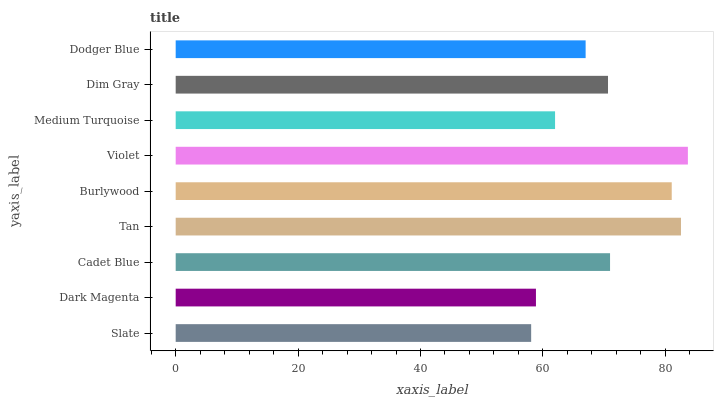Is Slate the minimum?
Answer yes or no. Yes. Is Violet the maximum?
Answer yes or no. Yes. Is Dark Magenta the minimum?
Answer yes or no. No. Is Dark Magenta the maximum?
Answer yes or no. No. Is Dark Magenta greater than Slate?
Answer yes or no. Yes. Is Slate less than Dark Magenta?
Answer yes or no. Yes. Is Slate greater than Dark Magenta?
Answer yes or no. No. Is Dark Magenta less than Slate?
Answer yes or no. No. Is Dim Gray the high median?
Answer yes or no. Yes. Is Dim Gray the low median?
Answer yes or no. Yes. Is Dark Magenta the high median?
Answer yes or no. No. Is Medium Turquoise the low median?
Answer yes or no. No. 